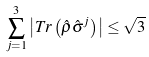Convert formula to latex. <formula><loc_0><loc_0><loc_500><loc_500>\sum _ { j = 1 } ^ { 3 } \left | T r \left ( \hat { \rho } \hat { \sigma } ^ { j } \right ) \right | \leq \sqrt { 3 }</formula> 